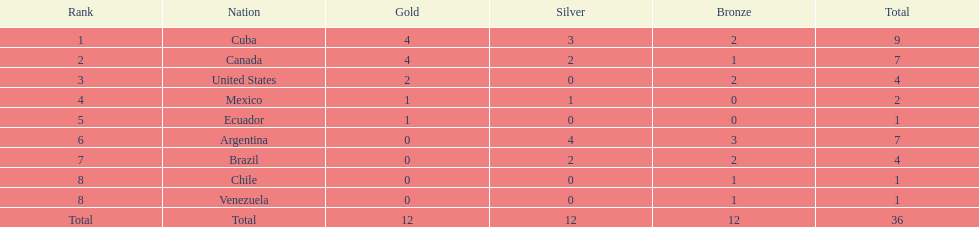How many medals has brazil been awarded in total? 4. 